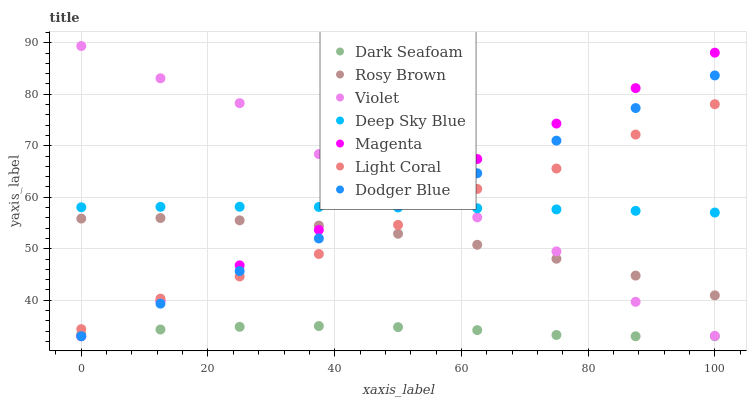Does Dark Seafoam have the minimum area under the curve?
Answer yes or no. Yes. Does Violet have the maximum area under the curve?
Answer yes or no. Yes. Does Light Coral have the minimum area under the curve?
Answer yes or no. No. Does Light Coral have the maximum area under the curve?
Answer yes or no. No. Is Magenta the smoothest?
Answer yes or no. Yes. Is Violet the roughest?
Answer yes or no. Yes. Is Light Coral the smoothest?
Answer yes or no. No. Is Light Coral the roughest?
Answer yes or no. No. Does Dark Seafoam have the lowest value?
Answer yes or no. Yes. Does Light Coral have the lowest value?
Answer yes or no. No. Does Violet have the highest value?
Answer yes or no. Yes. Does Light Coral have the highest value?
Answer yes or no. No. Is Dark Seafoam less than Rosy Brown?
Answer yes or no. Yes. Is Light Coral greater than Dark Seafoam?
Answer yes or no. Yes. Does Violet intersect Deep Sky Blue?
Answer yes or no. Yes. Is Violet less than Deep Sky Blue?
Answer yes or no. No. Is Violet greater than Deep Sky Blue?
Answer yes or no. No. Does Dark Seafoam intersect Rosy Brown?
Answer yes or no. No. 